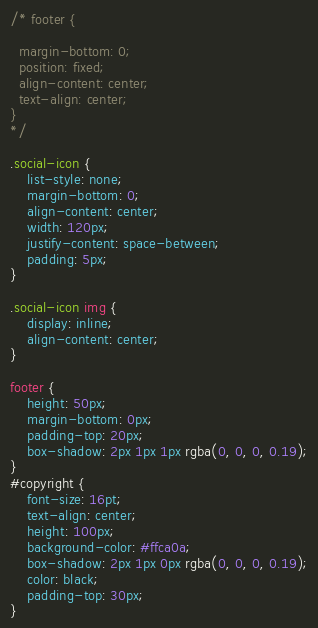Convert code to text. <code><loc_0><loc_0><loc_500><loc_500><_CSS_>/* footer {
 
  margin-bottom: 0;
  position: fixed;
  align-content: center;
  text-align: center;
}
*/

.social-icon {
	list-style: none;
	margin-bottom: 0;
	align-content: center;
	width: 120px;
	justify-content: space-between;
	padding: 5px;
}

.social-icon img {
	display: inline;
	align-content: center;
}

footer {
	height: 50px;
	margin-bottom: 0px;
	padding-top: 20px;
	box-shadow: 2px 1px 1px rgba(0, 0, 0, 0.19);
}
#copyright {
	font-size: 16pt;
	text-align: center;
	height: 100px;
	background-color: #ffca0a;
	box-shadow: 2px 1px 0px rgba(0, 0, 0, 0.19);
	color: black;
	padding-top: 30px;
}
</code> 